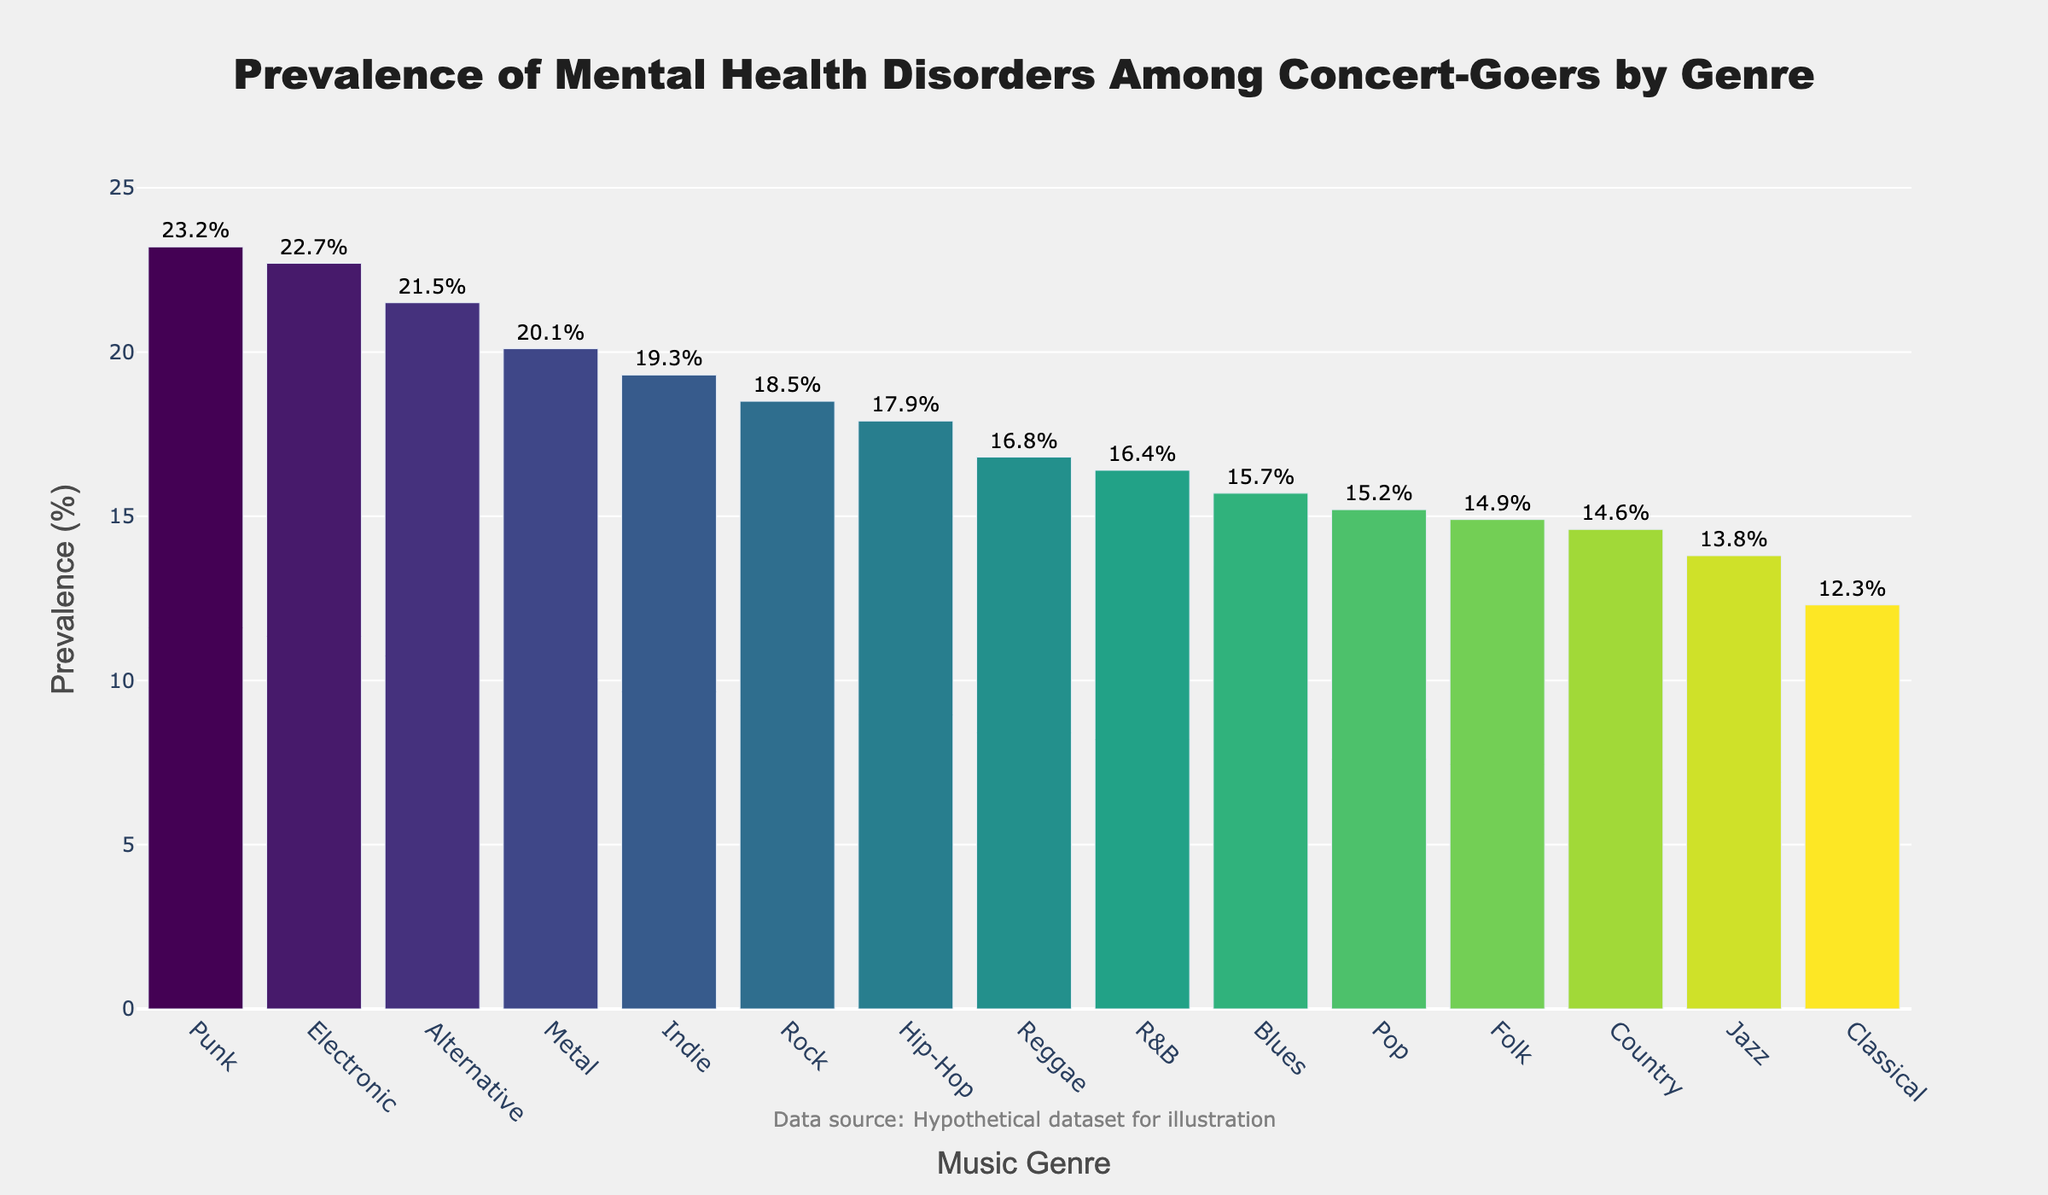What genre has the highest prevalence of mental health disorders among concert-goers? The highest prevalence bar is labeled as 23.2% and corresponds to the "Punk" genre.
Answer: Punk What is the difference in prevalence between the genre with the highest and the genre with the lowest mental health disorder prevalence? The highest prevalence is 23.2% (Punk) and the lowest is 12.3% (Classical). The difference is 23.2% - 12.3% = 10.9%.
Answer: 10.9% Which two genres have a prevalence percentage that collectively sums up to more than 40%? The top two highest are Punk (23.2%) and Electronic (22.7%), and their sum is 23.2% + 22.7% = 45.9%. This is more than 40%.
Answer: Punk and Electronic Which genre has a prevalence closest to the average prevalence percentage across all genres? The average prevalence is calculated as (sum of all prevalence percentages / number of genres). The total sum is 250.0% across 15 genres, so the average is 250.0 / 15 ≈ 16.67%. The closest genre is R&B at 16.4%.
Answer: R&B Arrange the top three genres with the highest prevalence in descending order. The three genres with the highest prevalence are: Punk (23.2%), Electronic (22.7%), and Alternative (21.5%). Arranged in descending: Punk, Electronic, Alternative.
Answer: Punk, Electronic, Alternative What is the collective prevalence percentage of the three genres with the least prevalence? The three genres with the least prevalence are Classical (12.3%), Jazz (13.8%), and Folk (14.9%). Their collective prevalence is 12.3% + 13.8% + 14.9% = 41.0%.
Answer: 41.0% Which bar is the shortest, and what is its prevalence and genre? The shortest bar corresponds to Classical, with a prevalence of 12.3%.
Answer: Classical, 12.3% How many genres have a prevalence percentage greater than 20%? List them. There are three genres: Punk (23.2%), Electronic (22.7%), and Alternative (21.5%).
Answer: Three: Punk, Electronic, Alternative What is the median prevalence percentage among the genres? To find the median, we first list the prevalence percentages in ascending order: 12.3, 13.8, 14.6, 14.9, 15.2, 15.7, 16.4, 16.8, 17.9, 18.5, 19.3, 20.1, 21.5, 22.7, 23.2. The median is the middle value, which is the 8th one: 16.8%.
Answer: 16.8% Which genre's prevalence is closest to the 20% mark? The closest prevalence to 20% is Metal with 20.1%.
Answer: Metal 